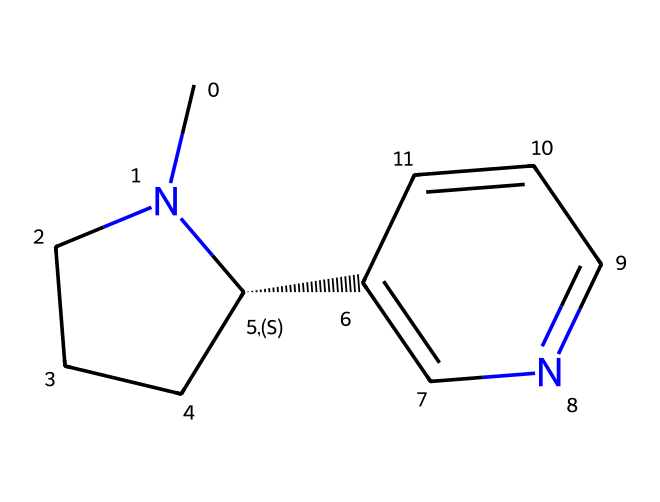What is the molecular formula of nicotine? To determine the molecular formula, count the atoms in the SMILES representation. The formula can be deduced as C10H14N2, comprising 10 carbon atoms, 14 hydrogen atoms, and 2 nitrogen atoms.
Answer: C10H14N2 How many rings are present in the structure of nicotine? Observing the SMILES representation, we can see two distinct cyclic structures: one from the piperidine ring and the other from the pyridine-like part. Thus, there are two rings.
Answer: 2 What is the primary functional group in nicotine? The SMILES indicates the presence of nitrogen atoms in a cyclic structure, leading to classification as a nitrogen-containing heterocycle, which identifies it primarily as an amine functional group.
Answer: amine Does nicotine contain any double bonds? Analyzing the structure, we identify double bonds present between certain carbon atoms and nitrogen atoms, indicating the presence of at least one double bond in the molecular composition.
Answer: yes Is nicotine considered an aromatic compound? Nicotine contains a benzene-like ring (the pyridine part), fulfilling criteria associated with aromatic compounds such as cyclic structure and conjugated π-electrons.
Answer: yes What is the total number of carbon atoms in nicotine? The total count of carbon atoms from the SMILES leads to a determination of ten carbon atoms in the molecular structure of nicotine.
Answer: 10 